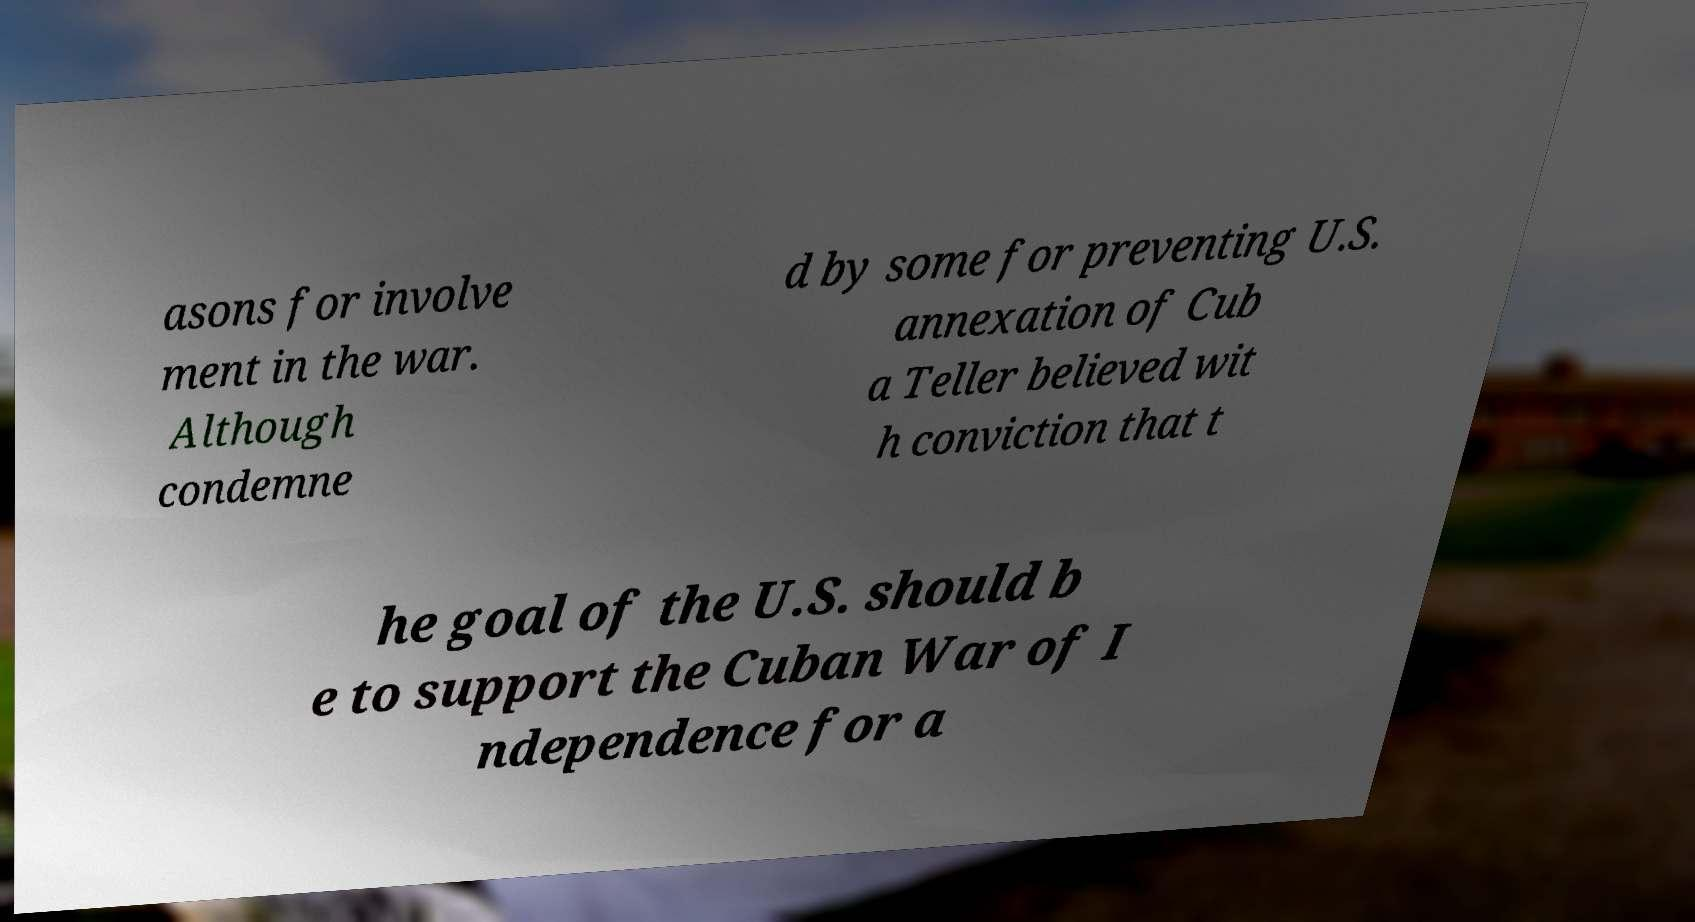I need the written content from this picture converted into text. Can you do that? asons for involve ment in the war. Although condemne d by some for preventing U.S. annexation of Cub a Teller believed wit h conviction that t he goal of the U.S. should b e to support the Cuban War of I ndependence for a 